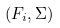<formula> <loc_0><loc_0><loc_500><loc_500>( F _ { i } , \Sigma )</formula> 